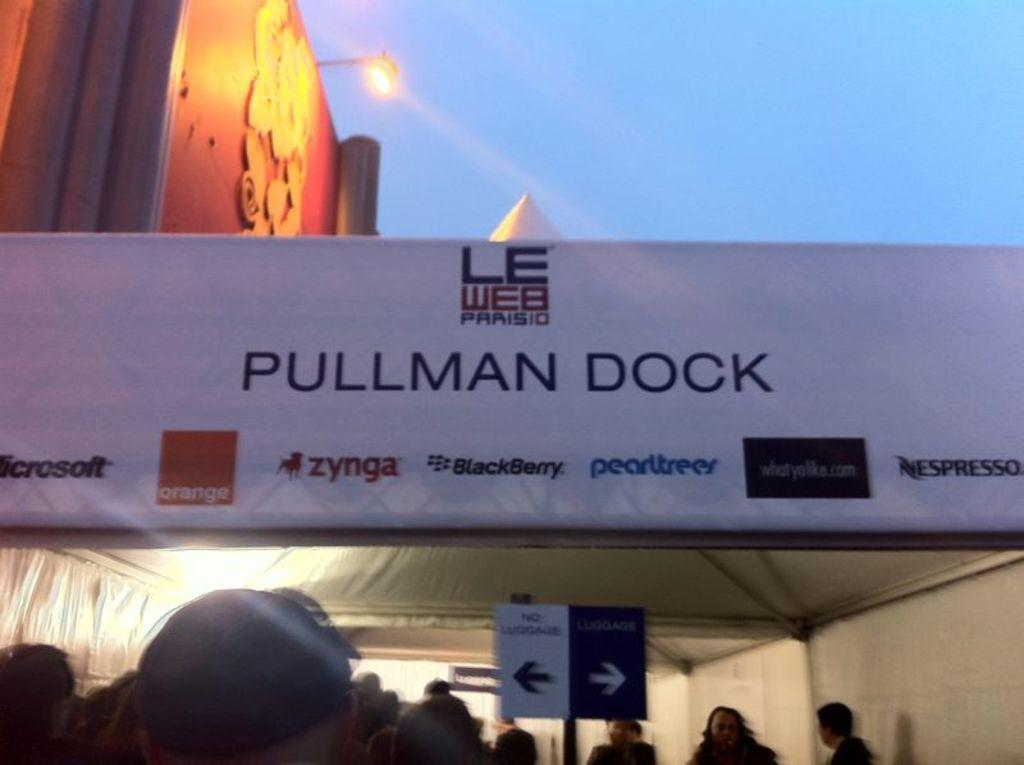<image>
Relay a brief, clear account of the picture shown. Pearltrees is one of the companies who supports Pullman Dock 